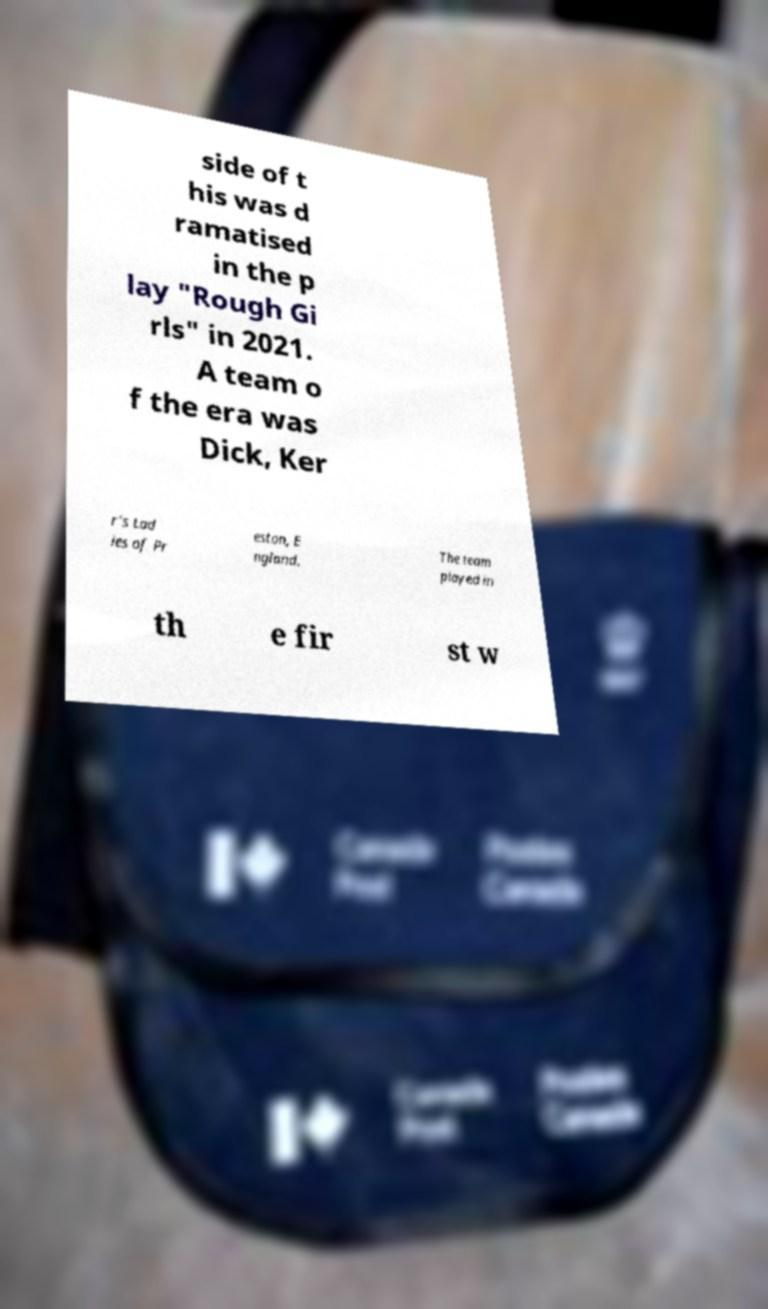Could you assist in decoding the text presented in this image and type it out clearly? side of t his was d ramatised in the p lay "Rough Gi rls" in 2021. A team o f the era was Dick, Ker r's Lad ies of Pr eston, E ngland. The team played in th e fir st w 